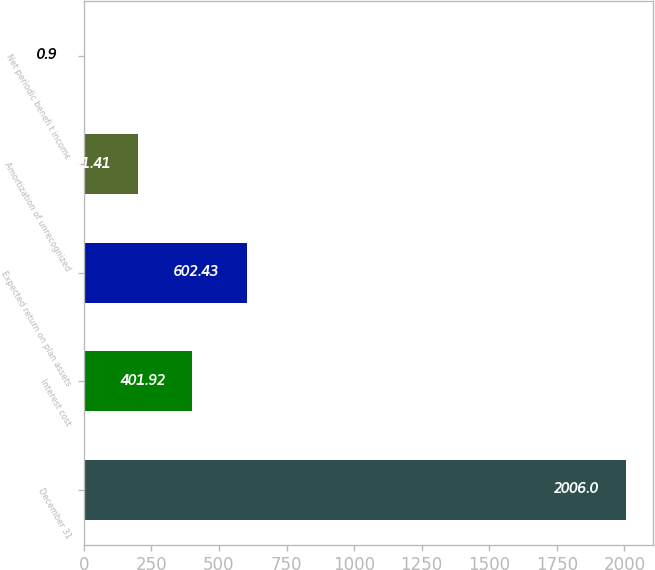Convert chart. <chart><loc_0><loc_0><loc_500><loc_500><bar_chart><fcel>December 31<fcel>Interest cost<fcel>Expected return on plan assets<fcel>Amortization of unrecognized<fcel>Net periodic benefi t income<nl><fcel>2006<fcel>401.92<fcel>602.43<fcel>201.41<fcel>0.9<nl></chart> 